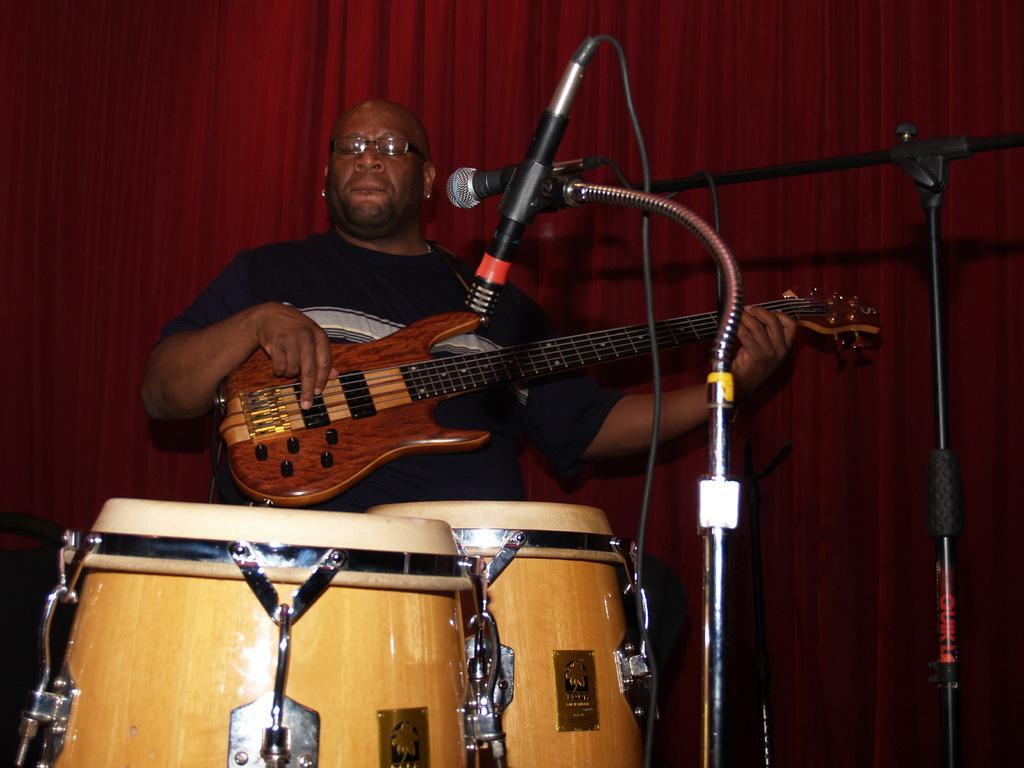In one or two sentences, can you explain what this image depicts? There is a man playing guitar. He has spectacles. And this is mike. There are musical drums. In the background there is a curtain. 